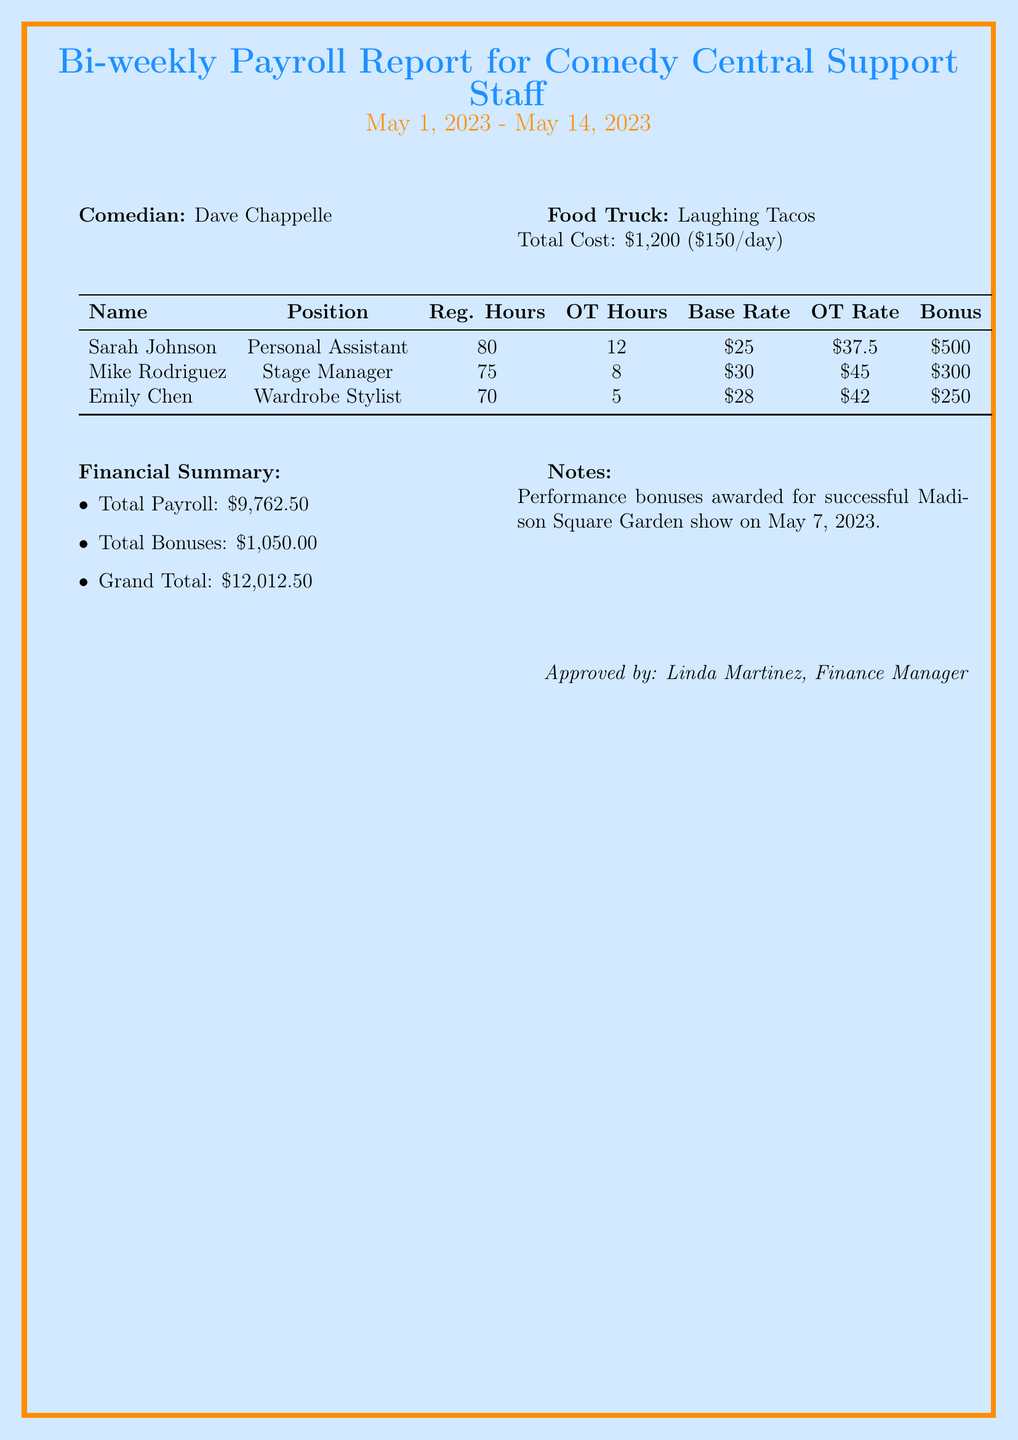What is the report title? The report title is clearly stated at the beginning of the document.
Answer: Bi-weekly Payroll Report for Comedy Central Support Staff What is the date range covered by the report? The date range is mentioned right under the report title.
Answer: May 1, 2023 - May 14, 2023 How many overtime hours did Sarah Johnson work? The number of overtime hours for each support staff member is listed in the table.
Answer: 12 What is the performance bonus for Mike Rodriguez? The performance bonus for each support staff member is noted in the document.
Answer: 300 What is the total cost for the food truck? The total cost of the food truck services is specified in the financial summary.
Answer: 1200 What is the grand total of the payroll report? The grand total is the final amount representing the total payroll plus bonuses.
Answer: 12012.5 How much is the overtime rate for Emily Chen? The overtime rate for each position is described in the payroll report table.
Answer: 42 Who approved the payroll report? The approver's information is listed at the bottom of the document.
Answer: Linda Martinez, Finance Manager What financial event occurred on May 7, 2023? The notes section specifies the reason for performance bonuses.
Answer: Successful Madison Square Garden show 